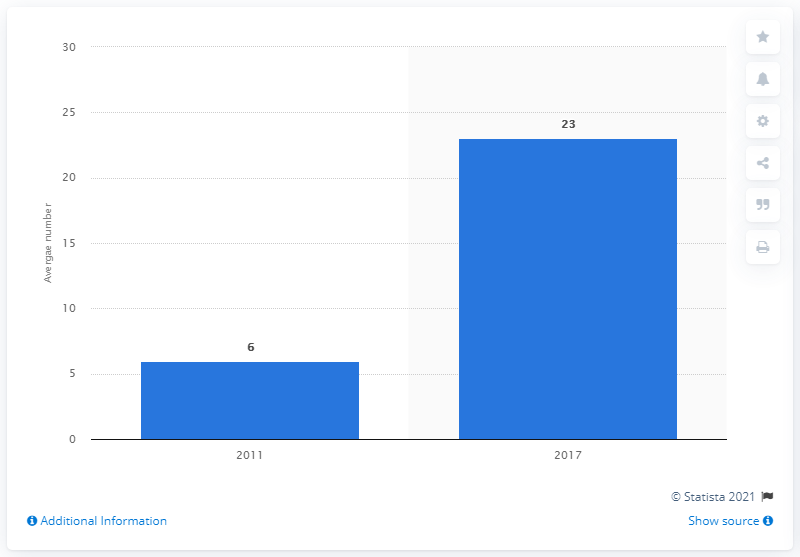Draw attention to some important aspects in this diagram. In 2017, approximately 23% of adults streamed Netflix daily. In 2017, approximately 23% of adults streamed Netflix daily, according to a survey. 